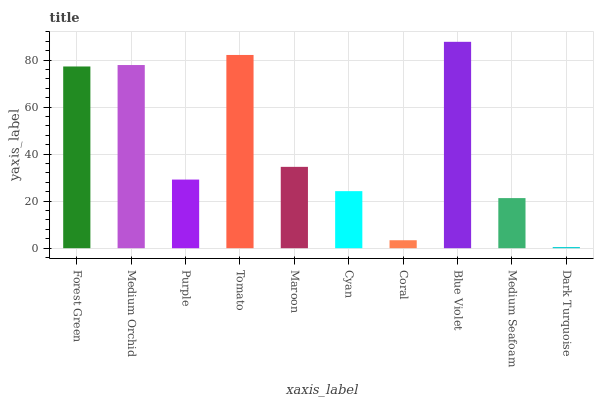Is Dark Turquoise the minimum?
Answer yes or no. Yes. Is Blue Violet the maximum?
Answer yes or no. Yes. Is Medium Orchid the minimum?
Answer yes or no. No. Is Medium Orchid the maximum?
Answer yes or no. No. Is Medium Orchid greater than Forest Green?
Answer yes or no. Yes. Is Forest Green less than Medium Orchid?
Answer yes or no. Yes. Is Forest Green greater than Medium Orchid?
Answer yes or no. No. Is Medium Orchid less than Forest Green?
Answer yes or no. No. Is Maroon the high median?
Answer yes or no. Yes. Is Purple the low median?
Answer yes or no. Yes. Is Medium Seafoam the high median?
Answer yes or no. No. Is Blue Violet the low median?
Answer yes or no. No. 